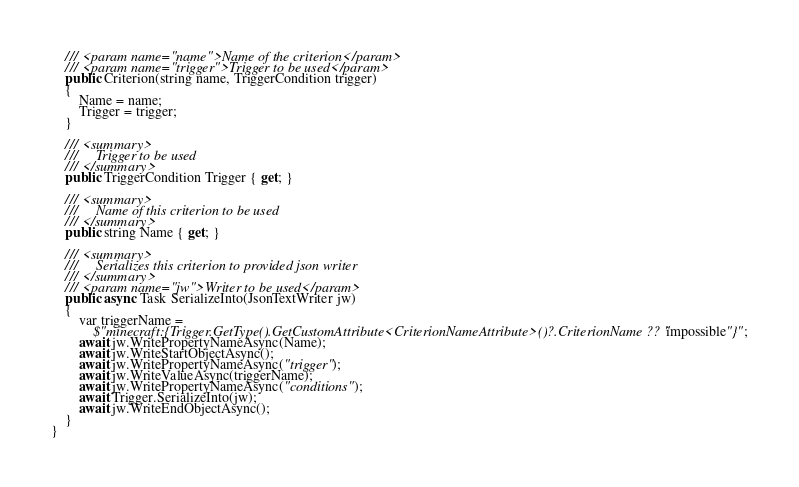Convert code to text. <code><loc_0><loc_0><loc_500><loc_500><_C#_>    /// <param name="name">Name of the criterion</param>
    /// <param name="trigger">Trigger to be used</param>
    public Criterion(string name, TriggerCondition trigger)
    {
        Name = name;
        Trigger = trigger;
    }

    /// <summary>
    ///     Trigger to be used
    /// </summary>
    public TriggerCondition Trigger { get; }

    /// <summary>
    ///     Name of this criterion to be used
    /// </summary>
    public string Name { get; }

    /// <summary>
    ///     Serializes this criterion to provided json writer
    /// </summary>
    /// <param name="jw">Writer to be used</param>
    public async Task SerializeInto(JsonTextWriter jw)
    {
        var triggerName =
            $"minecraft:{Trigger.GetType().GetCustomAttribute<CriterionNameAttribute>()?.CriterionName ?? "impossible"}";
        await jw.WritePropertyNameAsync(Name);
        await jw.WriteStartObjectAsync();
        await jw.WritePropertyNameAsync("trigger");
        await jw.WriteValueAsync(triggerName);
        await jw.WritePropertyNameAsync("conditions");
        await Trigger.SerializeInto(jw);
        await jw.WriteEndObjectAsync();
    }
}</code> 